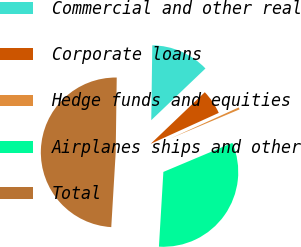<chart> <loc_0><loc_0><loc_500><loc_500><pie_chart><fcel>Commercial and other real<fcel>Corporate loans<fcel>Hedge funds and equities<fcel>Airplanes ships and other<fcel>Total<nl><fcel>12.66%<fcel>5.33%<fcel>0.45%<fcel>32.29%<fcel>49.28%<nl></chart> 